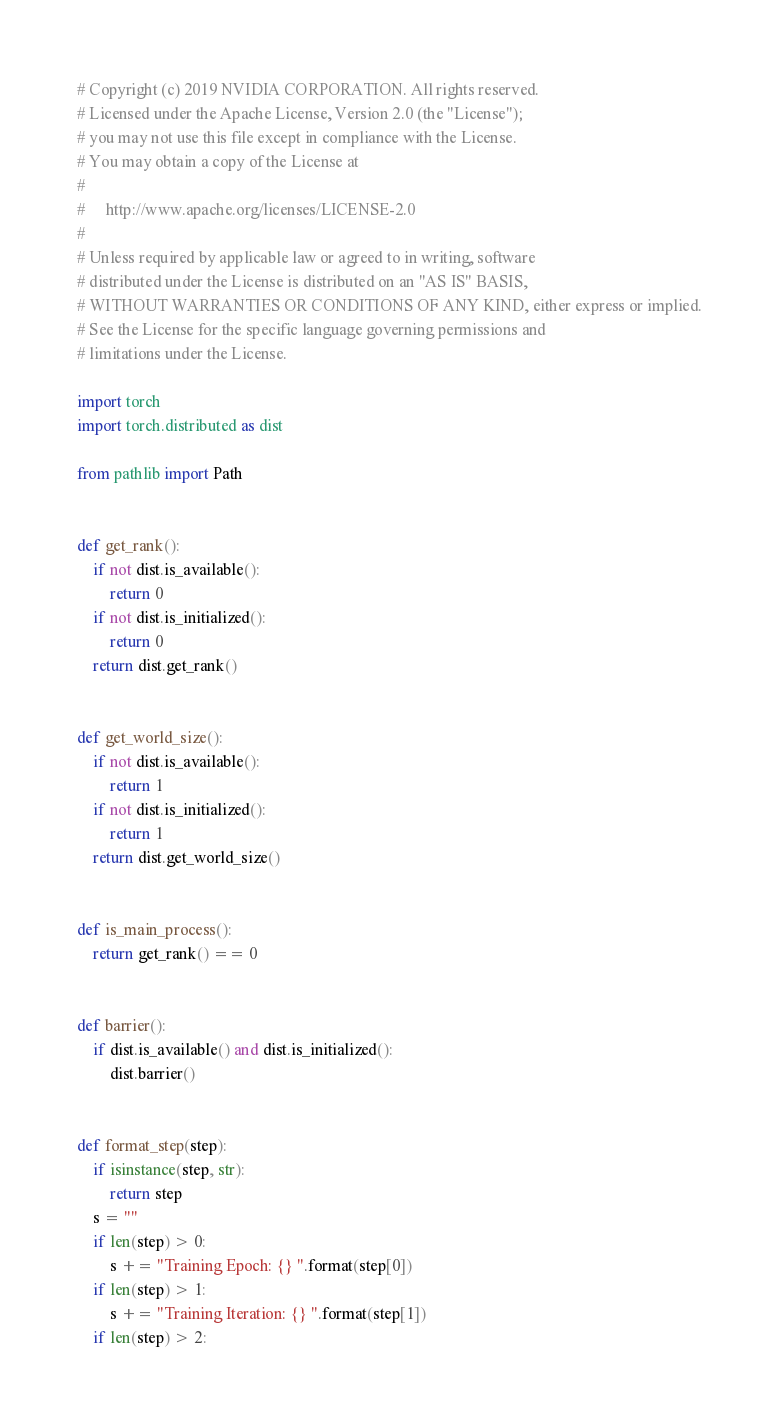Convert code to text. <code><loc_0><loc_0><loc_500><loc_500><_Python_># Copyright (c) 2019 NVIDIA CORPORATION. All rights reserved.
# Licensed under the Apache License, Version 2.0 (the "License");
# you may not use this file except in compliance with the License.
# You may obtain a copy of the License at
#
#     http://www.apache.org/licenses/LICENSE-2.0
#
# Unless required by applicable law or agreed to in writing, software
# distributed under the License is distributed on an "AS IS" BASIS,
# WITHOUT WARRANTIES OR CONDITIONS OF ANY KIND, either express or implied.
# See the License for the specific language governing permissions and
# limitations under the License.

import torch
import torch.distributed as dist

from pathlib import Path


def get_rank():
    if not dist.is_available():
        return 0
    if not dist.is_initialized():
        return 0
    return dist.get_rank()


def get_world_size():
    if not dist.is_available():
        return 1
    if not dist.is_initialized():
        return 1
    return dist.get_world_size()


def is_main_process():
    return get_rank() == 0


def barrier():
    if dist.is_available() and dist.is_initialized():
        dist.barrier()


def format_step(step):
    if isinstance(step, str):
        return step
    s = ""
    if len(step) > 0:
        s += "Training Epoch: {} ".format(step[0])
    if len(step) > 1:
        s += "Training Iteration: {} ".format(step[1])
    if len(step) > 2:</code> 